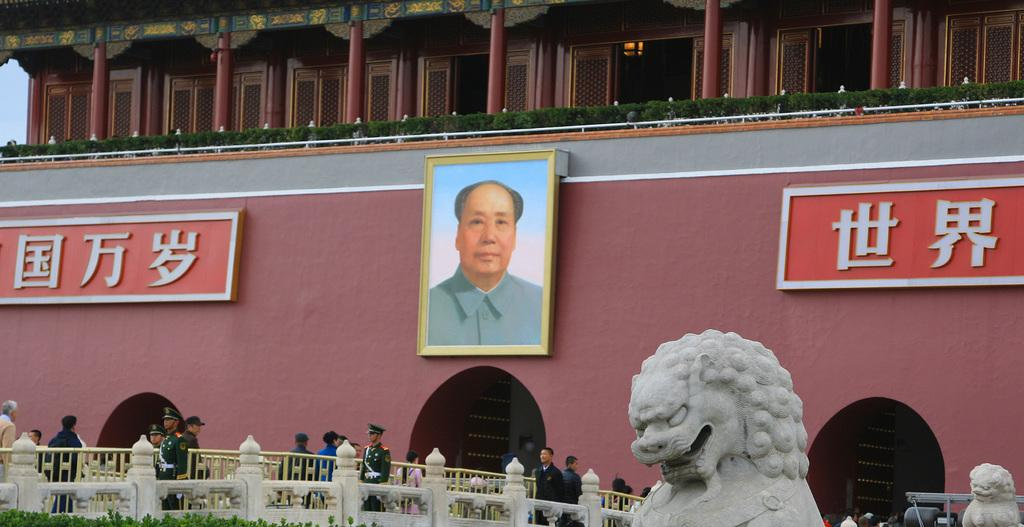What is attached to the building in the image? There are boards and photo frames attached to the building. What are the people in the image doing? The people walking on the ground in the image. Can you describe the sculpture in the image? Yes, there is a sculpture in the image. What type of vegetation is present in the image? There is grass in the image. What is the purpose of the fence in the image? The fence is present in the image. What can be seen in the sky in the image? The sky is visible in the image. How many friends are holding a pen in the image? There are no friends or pens present in the image. What type of connection can be seen between the people and the sculpture in the image? There is no connection between the people and the sculpture in the image; they are separate entities. 